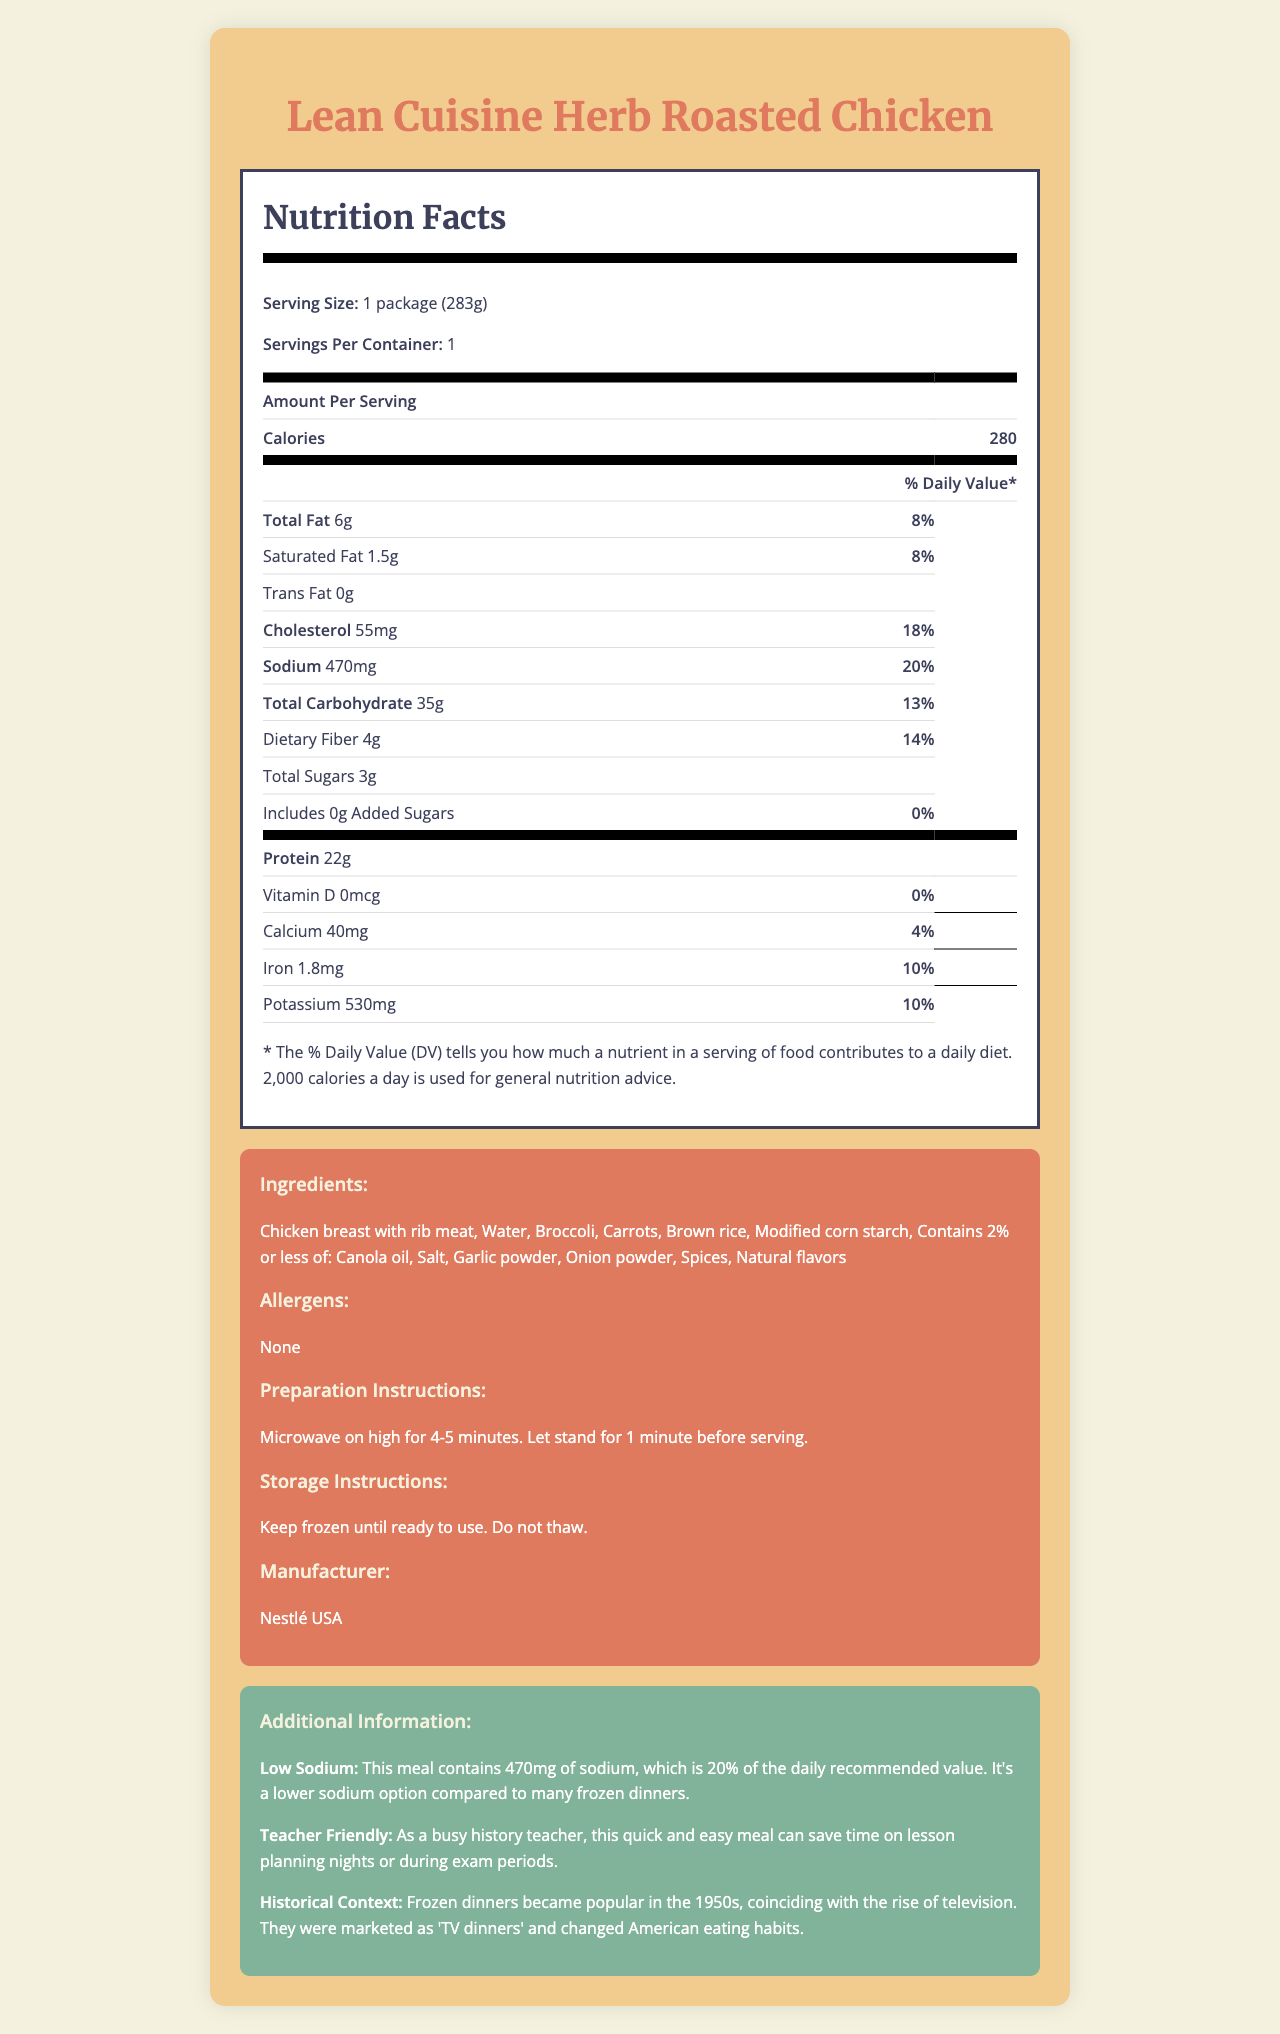what is the serving size of the Lean Cuisine Herb Roasted Chicken? The serving size of this product is listed as 1 package, which weighs 283 grams.
Answer: 1 package (283g) how many calories are in one serving of this frozen dinner? The label shows that one serving contains 280 calories.
Answer: 280 calories how much total fat is in one serving? The document states that there are 6 grams of total fat per serving.
Answer: 6g what percentage of the daily value does the sodium content represent? The sodium content in one serving is 470 milligrams, which is 20% of the daily value.
Answer: 20% what are the main ingredients of the Lean Cuisine Herb Roasted Chicken? The ingredients section lists these as the main ingredients.
Answer: Chicken breast with rib meat, Water, Broccoli, Carrots, Brown rice, Modified corn starch how long should you microwave the Lean Cuisine Herb Roasted Chicken? The preparation instructions state to microwave on high for 4-5 minutes.
Answer: 4-5 minutes what is the daily value percentage of iron in this product? A. 4% B. 10% C. 14% D. 20% The label indicates that the iron content is 1.8mg, which corresponds to 10% of the daily value.
Answer: B. 10% what nutrient has 0% daily value in this meal? A. Vitamin D B. Calcium C. Iron D. Potassium Vitamin D has an amount of 0mcg and a daily value percentage of 0%.
Answer: A. Vitamin D is this product allergen-free? The allergen section of the document states "None," indicating no allergens are present.
Answer: Yes does this product include added sugars? The document indicates that there are no added sugars (0g) in this product.
Answer: No summarize the main idea of the entire document The nutrition facts label offers an overview of the nutritional value, ingredients, and other pertinent details related to the product, aimed at helping consumers make informed choices. It also includes additional context aimed at a specific target audience.
Answer: The document provides a detailed nutrition label for Lean Cuisine Herb Roasted Chicken, a low-sodium frozen dinner option. It includes information about the serving size, nutritional content, ingredients, preparation, storage instructions, and additional context about its benefits for busy individuals and a brief historical context about frozen dinners. what is the size of the package? The serving size line states that the package size is 283 grams.
Answer: 283g how much protein does this product contain? The nutrition facts state that the product contains 22 grams of protein per serving.
Answer: 22g is this product manufactured by Nestlé USA? The manufacturer section confirms that Nestlé USA is the manufacturer of this product.
Answer: Yes when did frozen dinners become popular in America? The additional information section notes that frozen dinners became popular in the 1950s.
Answer: 1950s which of the following is not an ingredient in the Lean Cuisine Herb Roasted Chicken? A. Carrots B. Brown rice C. Potatoes D. Garlic powder The ingredients list does not mention potatoes as an ingredient in this product.
Answer: C. Potatoes is the daily value percentage shown for trans fat? The trans fat content is listed as 0g and doesn't display a daily value percentage on the label.
Answer: No how should the product be stored until ready to use? The storage instructions specify that the product should be kept frozen and not thawed before use.
Answer: Keep frozen until ready to use. Do not thaw. what are the historical roots of the term "TV dinners"? The additional information provides this context, explaining how frozen dinners were marketed in the 1950s.
Answer: Frozen dinners became popular in the 1950s, coinciding with the rise of television. They were marketed as 'TV dinners' and changed American eating habits. what are the daily value percentages for calcium and potassium? The document lists the daily value as 4% for calcium and 10% for potassium.
Answer: Calcium: 4%, Potassium: 10% can you determine the cost of one package of Lean Cuisine Herb Roasted Chicken from the document? The document does not provide any pricing information for the product.
Answer: Not enough information 